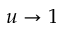Convert formula to latex. <formula><loc_0><loc_0><loc_500><loc_500>u \rightarrow 1</formula> 